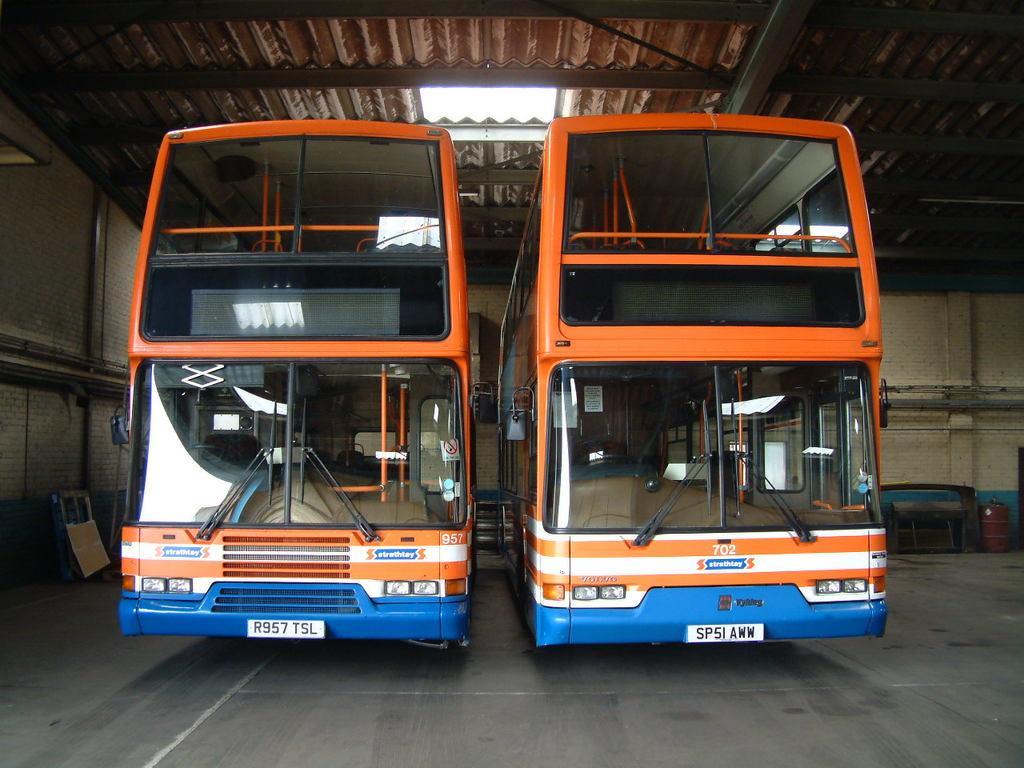Describe this image in one or two sentences. In the center of the image, we can see double decker buses inside the shed and at the top, there is roof. 